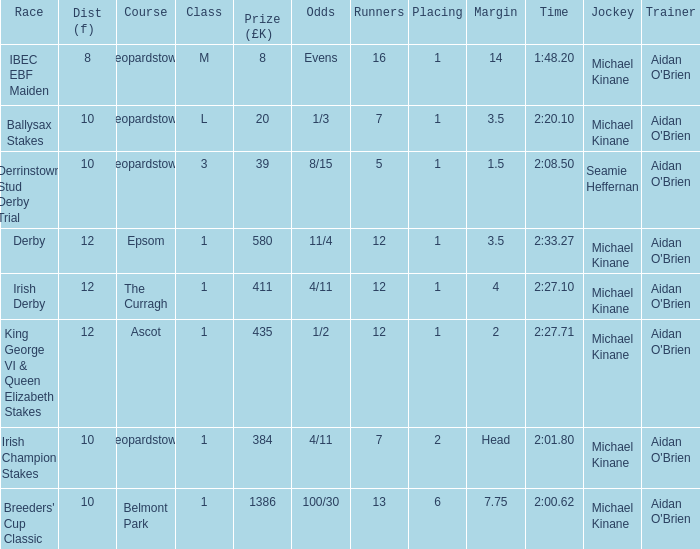Which Dist (f) has a Race of irish derby? 12.0. 